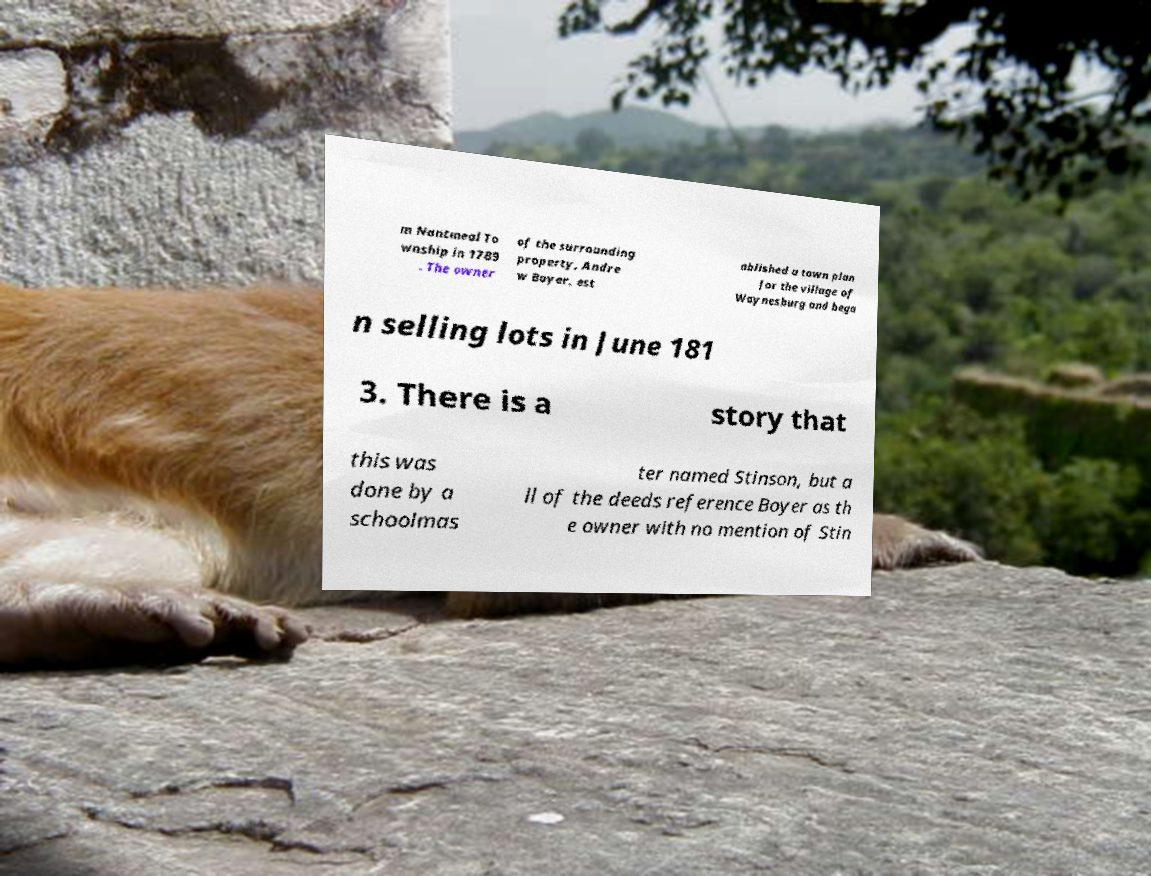What messages or text are displayed in this image? I need them in a readable, typed format. m Nantmeal To wnship in 1789 . The owner of the surrounding property, Andre w Boyer, est ablished a town plan for the village of Waynesburg and bega n selling lots in June 181 3. There is a story that this was done by a schoolmas ter named Stinson, but a ll of the deeds reference Boyer as th e owner with no mention of Stin 